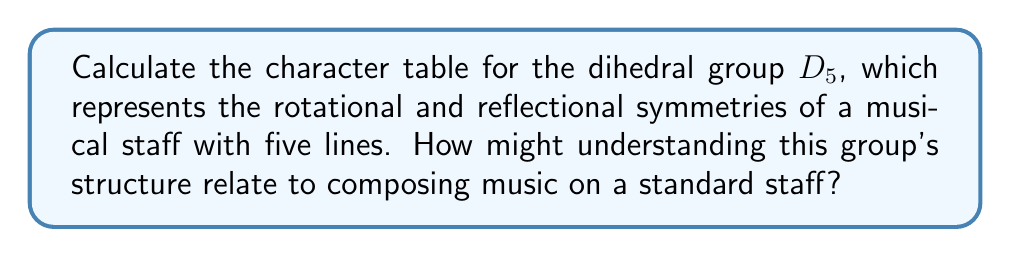Could you help me with this problem? Let's approach this step-by-step:

1) First, we need to understand the structure of $D_5$:
   - It has 10 elements: 5 rotations (including identity) and 5 reflections
   - The order of the group is 10

2) The conjugacy classes of $D_5$ are:
   - $\{e\}$ (identity)
   - $\{r, r^4\}$ (rotations by 72° and 288°)
   - $\{r^2, r^3\}$ (rotations by 144° and 216°)
   - $\{s, sr, sr^2, sr^3, sr^4\}$ (all reflections)

3) We have 4 conjugacy classes, so there will be 4 irreducible representations.

4) The irreducible representations are:
   - Two 1-dimensional representations: trivial and sign
   - Two 2-dimensional representations

5) Let's calculate the characters:

   For the trivial representation: $\chi_1(g) = 1$ for all $g$

   For the sign representation: 
   $\chi_2(r^k) = 1$, $\chi_2(sr^k) = -1$

   For the 2D representations, we use the formula:
   $$\chi_j(r^k) = 2\cos(2\pi jk/5)$$
   $$\chi_j(sr^k) = 0$$

6) Putting this all together, we get the character table:

   $$\begin{array}{c|cccc}
      D_5 & \{e\} & \{r,r^4\} & \{r^2,r^3\} & \{s,sr,sr^2,sr^3,sr^4\} \\
      \hline
      \chi_1 & 1 & 1 & 1 & 1 \\
      \chi_2 & 1 & 1 & 1 & -1 \\
      \chi_3 & 2 & 2\cos(2\pi/5) & 2\cos(4\pi/5) & 0 \\
      \chi_4 & 2 & 2\cos(4\pi/5) & 2\cos(8\pi/5) & 0
   \end{array}$$

7) Relating this to music composition:
   Understanding the symmetries of the musical staff can inspire creative ways to manipulate melodies. For example, rotations could represent transpositions, while reflections could represent inversions of musical phrases. This mathematical structure could guide the development of motifs and themes in a composition, ensuring a balance between repetition and variation.
Answer: Character table of $D_5$:
$$\begin{array}{c|cccc}
   D_5 & \{e\} & \{r,r^4\} & \{r^2,r^3\} & \{s,sr,sr^2,sr^3,sr^4\} \\
   \hline
   \chi_1 & 1 & 1 & 1 & 1 \\
   \chi_2 & 1 & 1 & 1 & -1 \\
   \chi_3 & 2 & 2\cos(2\pi/5) & 2\cos(4\pi/5) & 0 \\
   \chi_4 & 2 & 2\cos(4\pi/5) & 2\cos(8\pi/5) & 0
\end{array}$$ 